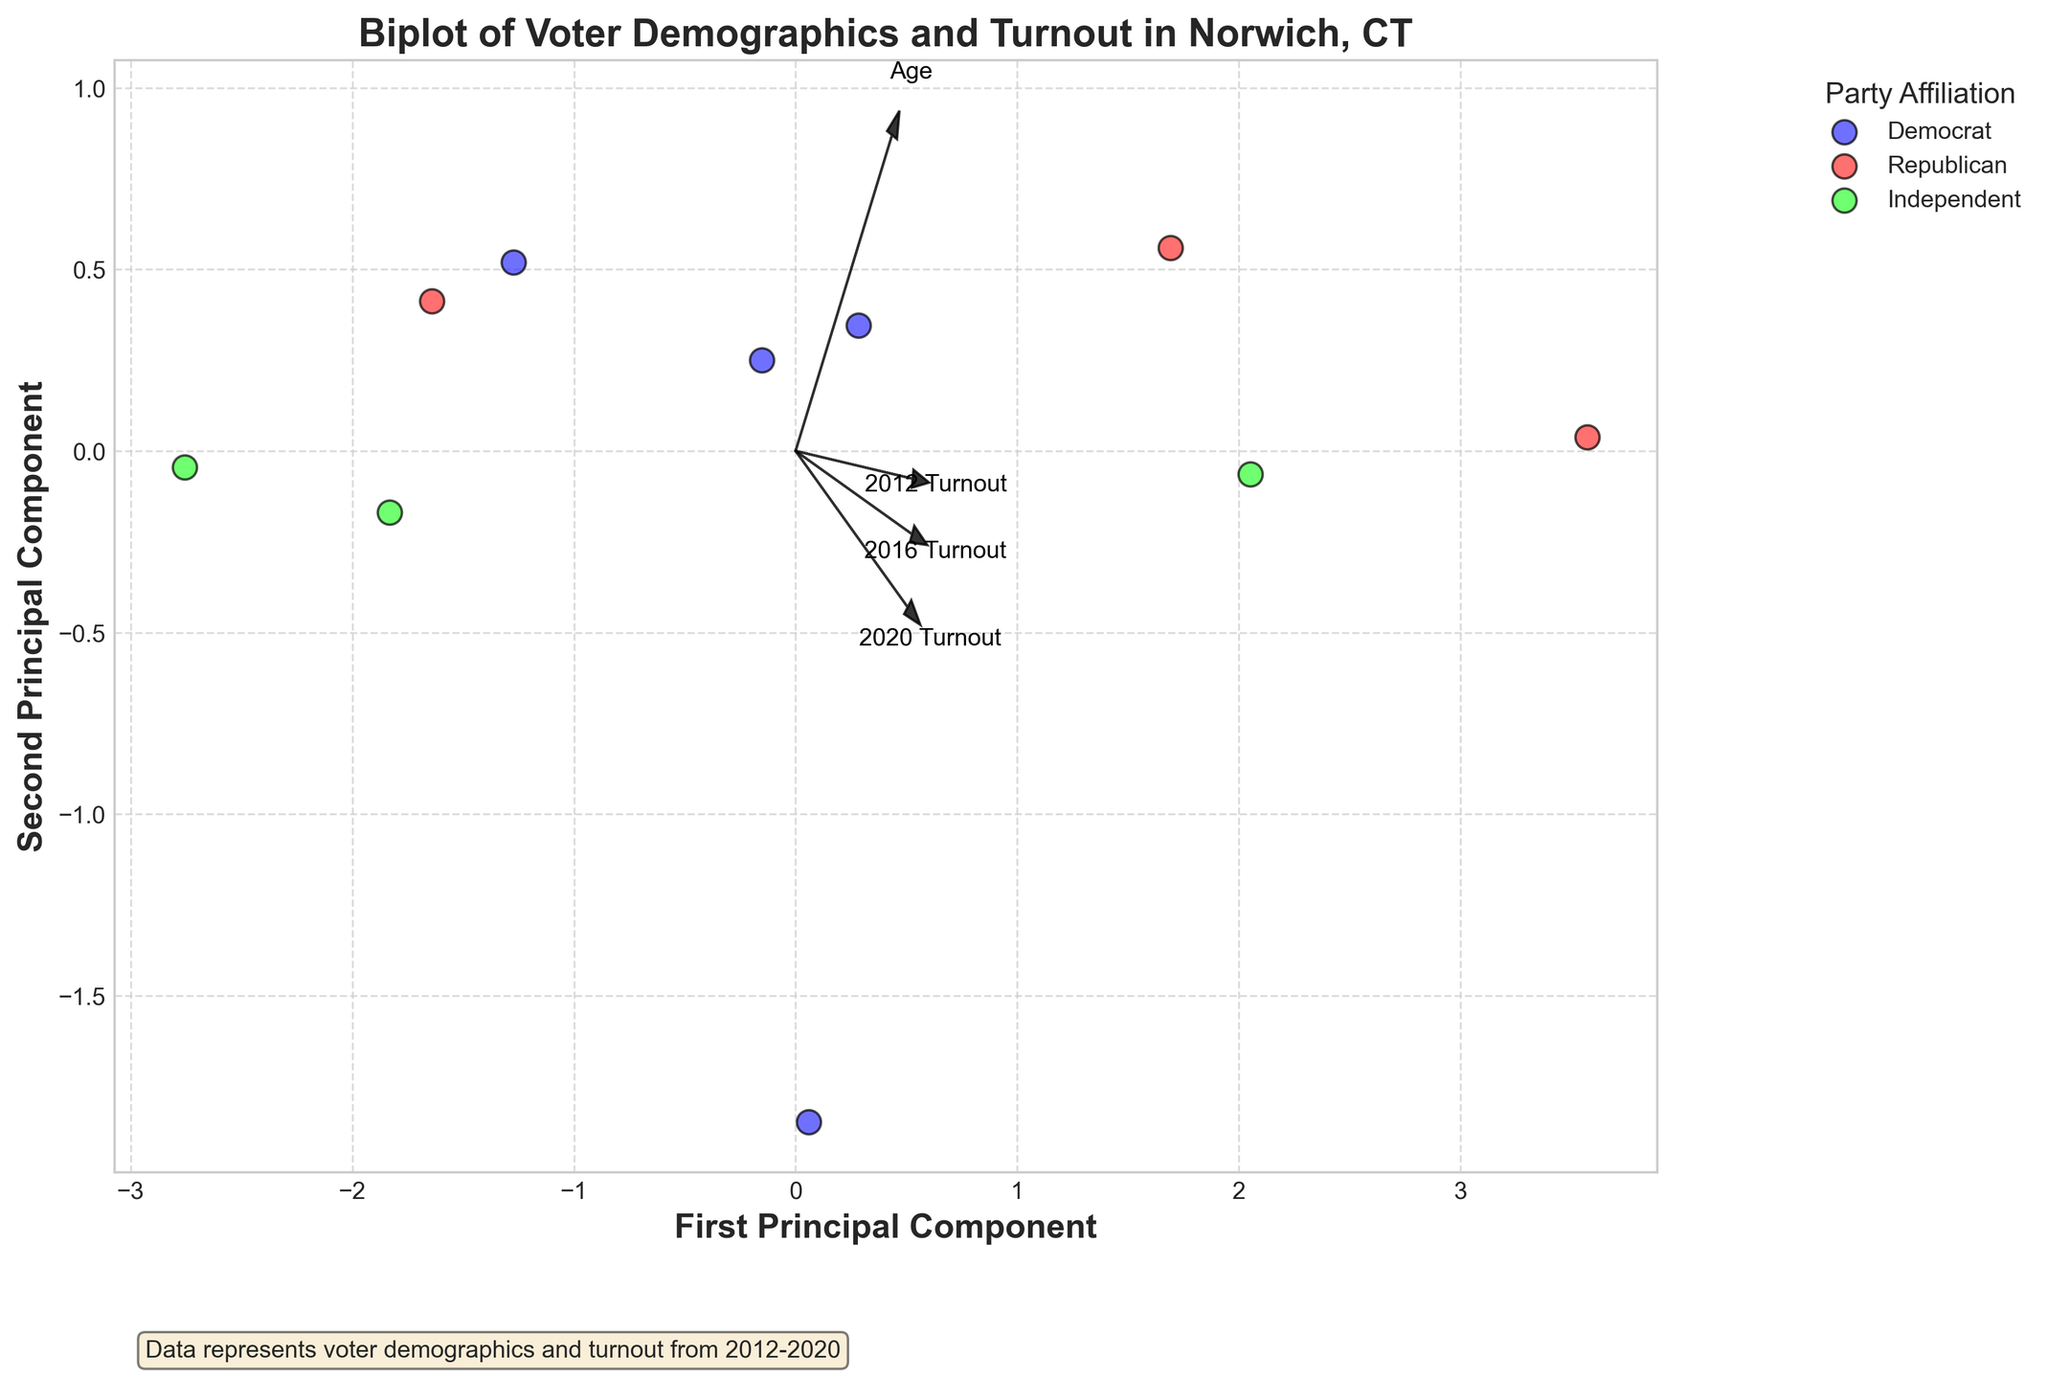What is the title of the plot? The title is located at the top of the plot, in bold and larger font. By reading it, we can see the title is "Biplot of Voter Demographics and Turnout in Norwich, CT."
Answer: Biplot of Voter Demographics and Turnout in Norwich, CT Which political party has data points colored blue? The legend on the right side of the plot shows the colors representing each party. The blue color represents the Democrat party.
Answer: Democrat How many principal components are used in this plot? The x-axis and y-axis labels of the plot indicate the components, "First Principal Component" and "Second Principal Component," showing that two principal components are used.
Answer: Two Which feature has the longest vector in the biplot? The length of the feature vectors is visually noticeable. The "2020 Turnout" vector appears longest, indicating it has the most variance explained by the principal components.
Answer: 2020 Turnout Which party shows data points clustered towards the right side of the first principal component? By looking at the scatter plot, the blue points (Democrats) are more clustered towards the right side of the first principal component.
Answer: Democrat Which feature is least correlated with the principal components? The vector closest to the origin has the least influence, indicating the least correlation. The "Age" vector appears shortest, suggesting the least correlation with the principal components.
Answer: Age Compare the voter turnout vectors from 2012 to 2020. Which one has the largest increase in voter turnout? We compare the direction and length of the vectors for "2012 Turnout," "2016 Turnout," and "2020 Turnout." The "2020 Turnout" vector is the longest and shows the largest increase in turnout.
Answer: 2020 Turnout Between the Republican and Independent parties, which has a more dispersed (spread out) distribution of data points? By observing the plot, the green (Independent) points are more scattered than the red (Republican) points, suggesting a more dispersed distribution.
Answer: Independent What can you infer about the relationship between education level and party affiliation based on the biplot? While the education level data is not directly given in the plot, we can infer that the relationships might be more complex. The clustering and spread of different party's data points can give us insight that education level may have a varied influence across different affiliations.
Answer: Complex relationship What does the second principal component tell us in this biplot? The second principal component gives us insights into the variance explained by factors other than the first principal component. It suggests additional dimensions like voter turnout changes over time and demographic variance within the dataset which are not captured by the first principal component.
Answer: Additional demographic and turnout variance 